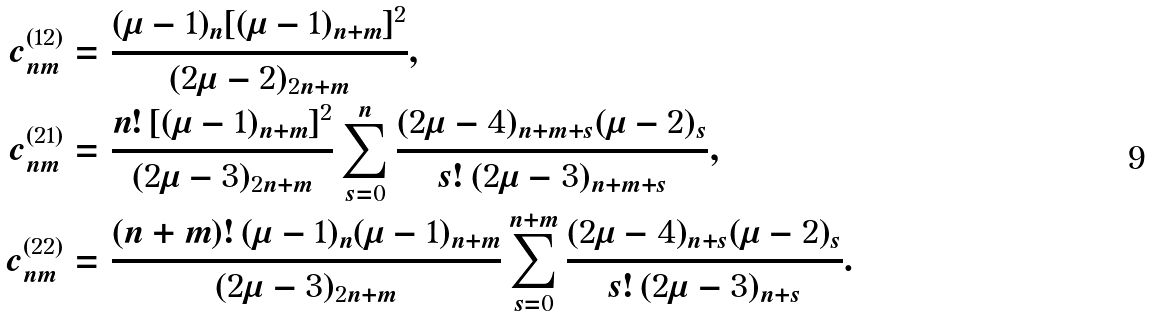<formula> <loc_0><loc_0><loc_500><loc_500>c _ { n m } ^ { ( 1 2 ) } & = \frac { ( \mu - 1 ) _ { n } [ ( \mu - 1 ) _ { n + m } ] ^ { 2 } } { ( 2 \mu - 2 ) _ { 2 n + m } } , \\ c _ { n m } ^ { ( 2 1 ) } & = \frac { n ! \, [ ( \mu - 1 ) _ { n + m } ] ^ { 2 } } { ( 2 \mu - 3 ) _ { 2 n + m } } \sum _ { s = 0 } ^ { n } \frac { ( 2 \mu - 4 ) _ { n + m + s } ( \mu - 2 ) _ { s } } { s ! \, ( 2 \mu - 3 ) _ { n + m + s } } , \\ c _ { n m } ^ { ( 2 2 ) } & = \frac { ( n + m ) ! \, ( \mu - 1 ) _ { n } ( \mu - 1 ) _ { n + m } } { ( 2 \mu - 3 ) _ { 2 n + m } } \sum _ { s = 0 } ^ { n + m } \frac { ( 2 \mu - 4 ) _ { n + s } ( \mu - 2 ) _ { s } } { s ! \, ( 2 \mu - 3 ) _ { n + s } } .</formula> 